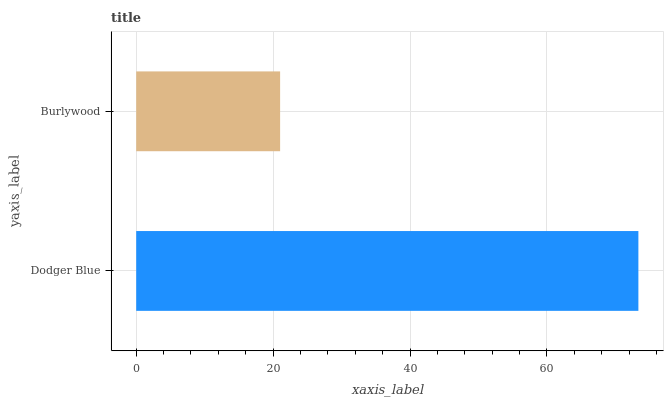Is Burlywood the minimum?
Answer yes or no. Yes. Is Dodger Blue the maximum?
Answer yes or no. Yes. Is Burlywood the maximum?
Answer yes or no. No. Is Dodger Blue greater than Burlywood?
Answer yes or no. Yes. Is Burlywood less than Dodger Blue?
Answer yes or no. Yes. Is Burlywood greater than Dodger Blue?
Answer yes or no. No. Is Dodger Blue less than Burlywood?
Answer yes or no. No. Is Dodger Blue the high median?
Answer yes or no. Yes. Is Burlywood the low median?
Answer yes or no. Yes. Is Burlywood the high median?
Answer yes or no. No. Is Dodger Blue the low median?
Answer yes or no. No. 